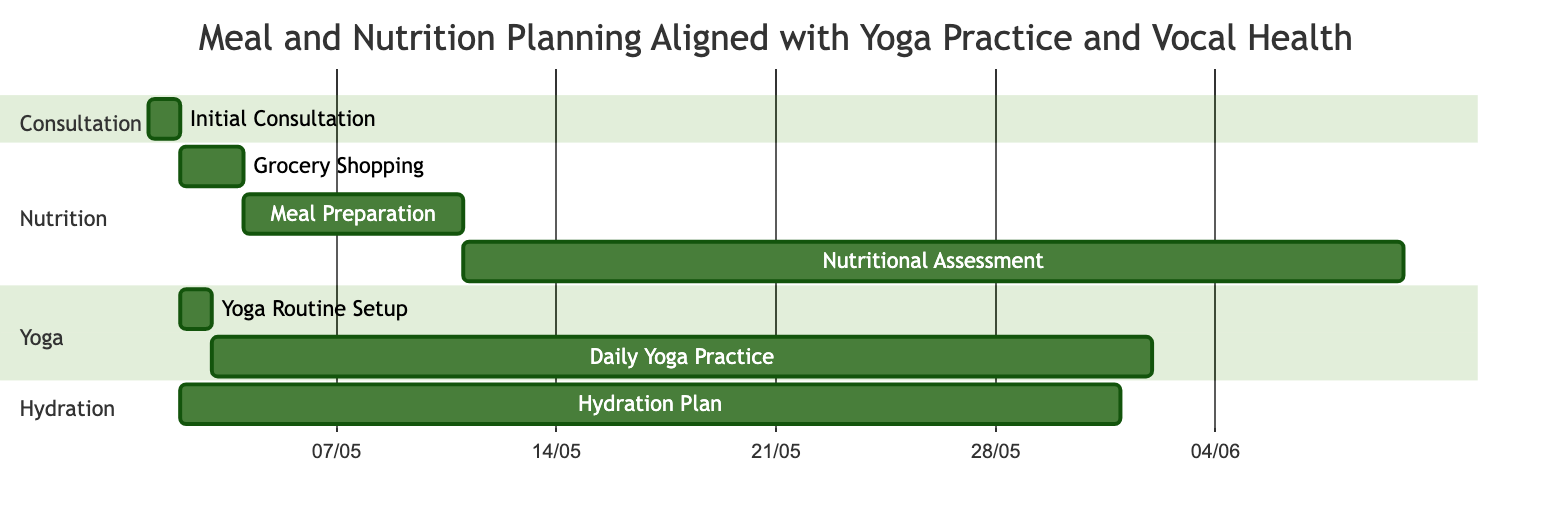What is the duration of the Initial Consultation? The diagram indicates that the Initial Consultation lasts for 1 day, as specified in its details.
Answer: 1 day How many days does the Meal Preparation take? The Meal Preparation activity shown in the diagram has a duration of 7 days according to its details.
Answer: 7 days Which activity follows Grocery Shopping? According to the dependencies in the Gantt chart, Meal Preparation is listed as the activity that begins following Grocery Shopping.
Answer: Meal Preparation What is the total duration for the Daily Yoga Practice? The Daily Yoga Practice is indicated to have a duration of 30 days in the diagram, as detailed in the activity information.
Answer: 30 days What activities are dependent on the Initial Consultation? The Gantt chart shows that Grocery Shopping, Yoga Routine Setup, and Hydration Plan are all dependent on the Initial Consultation.
Answer: Grocery Shopping, Yoga Routine Setup, Hydration Plan What activity lasts the longest after the Initial Consultation? Reviewing the durations, Nutritional Assessment has the longest duration of 30 days, following the Initial Consultation completion.
Answer: Nutritional Assessment What is the total number of activities in this Gantt chart? By counting each individual activity represented in the Gantt chart including all sections, there are a total of 7 distinct activities.
Answer: 7 Which section contains the Hydration Plan activity? The Hydration Plan is classified under the Hydration section as indicated by the structure of the Gantt chart.
Answer: Hydration What is the dependency of Daily Yoga Practice? The diagram specifies that Daily Yoga Practice is dependent on the Yoga Routine Setup, meaning that it cannot begin until that is completed.
Answer: Yoga Routine Setup 